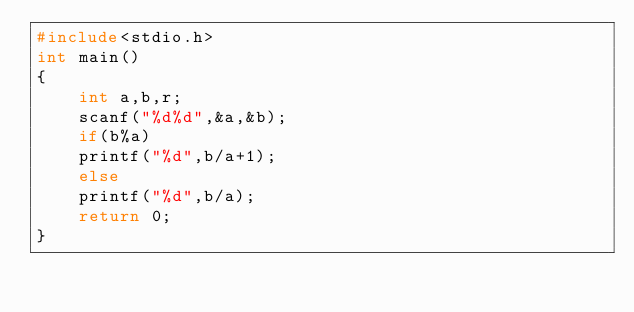Convert code to text. <code><loc_0><loc_0><loc_500><loc_500><_C_>#include<stdio.h>
int main()
{
    int a,b,r;
    scanf("%d%d",&a,&b);
    if(b%a)
    printf("%d",b/a+1);
    else
    printf("%d",b/a);
    return 0;
}</code> 